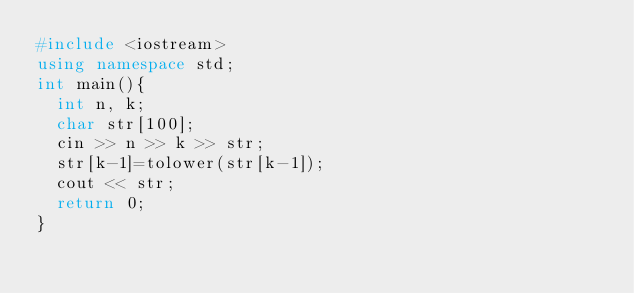<code> <loc_0><loc_0><loc_500><loc_500><_C++_>#include <iostream>
using namespace std;
int main(){
  int n, k;
  char str[100];
  cin >> n >> k >> str;
  str[k-1]=tolower(str[k-1]);
  cout << str;
  return 0;
}
</code> 